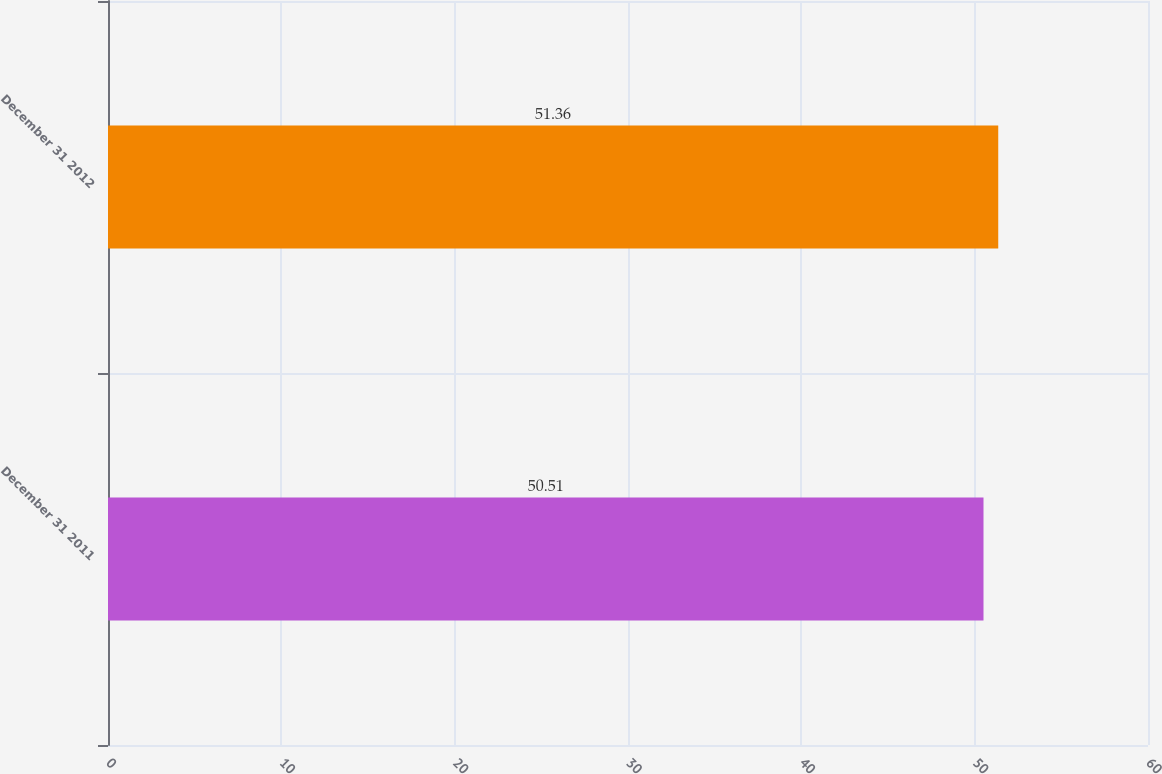<chart> <loc_0><loc_0><loc_500><loc_500><bar_chart><fcel>December 31 2011<fcel>December 31 2012<nl><fcel>50.51<fcel>51.36<nl></chart> 